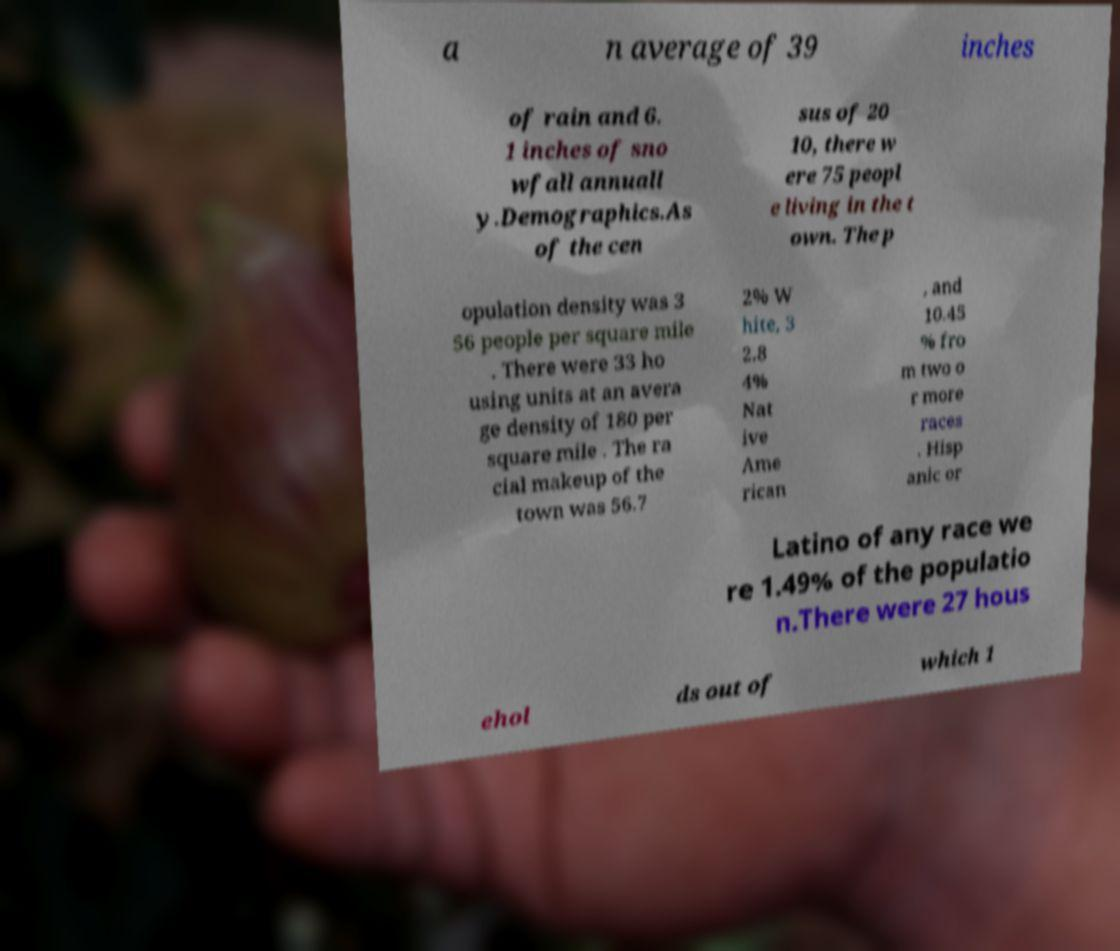What messages or text are displayed in this image? I need them in a readable, typed format. a n average of 39 inches of rain and 6. 1 inches of sno wfall annuall y.Demographics.As of the cen sus of 20 10, there w ere 75 peopl e living in the t own. The p opulation density was 3 56 people per square mile . There were 33 ho using units at an avera ge density of 180 per square mile . The ra cial makeup of the town was 56.7 2% W hite, 3 2.8 4% Nat ive Ame rican , and 10.45 % fro m two o r more races . Hisp anic or Latino of any race we re 1.49% of the populatio n.There were 27 hous ehol ds out of which 1 